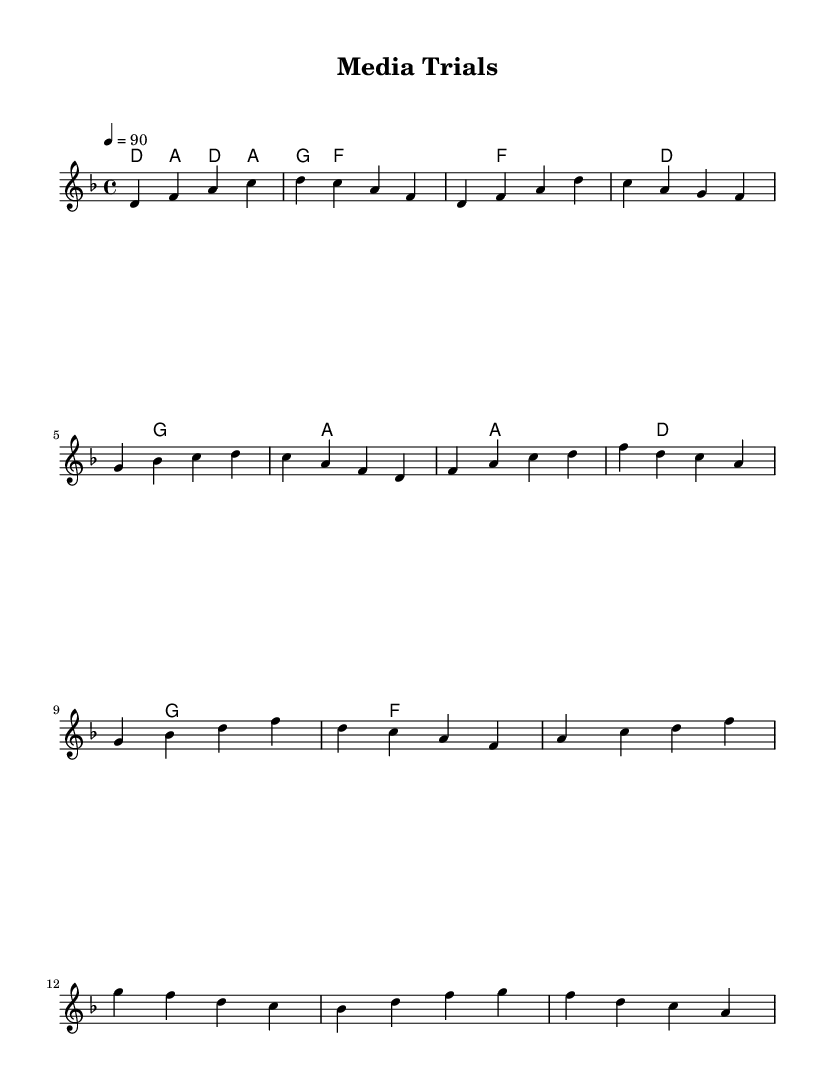What is the key signature of this music? The key signature is D minor, which contains one flat (B flat). It can be identified by looking at the left side of the staff, where the flats are indicated.
Answer: D minor What is the time signature of this music? The time signature is 4/4. This is found at the beginning of the score, indicating that there are four beats in each measure and the quarter note receives one beat.
Answer: 4/4 What is the tempo marking for this piece? The tempo is marked at 90 beats per minute, which is indicated above the staff. This guides the performer on how fast to play the piece.
Answer: 90 How many sections are there in the music? The music has four distinct sections: Intro, Verse, Chorus, and Bridge. This can be determined by examining the structure indicated in the melody part where each section is labeled or separated.
Answer: Four What chords are used in the chorus? The chords used in the chorus are F, D minor, G, and A minor. These can be found under the chorus section in the harmonies part, where the corresponding chord symbols are written.
Answer: F, D minor, G, A minor Which musical element is most suited for rap? The element that is most suited for rap is rhythm. In rap, rhythm plays a crucial role as it drives the flow and timing of lyrics. This is evident in how the melody is structured with clear beats and rhythmic patterns.
Answer: Rhythm What type of lyrical content does this rap explore? This rap explores socially conscious themes, particularly the impact of media on high-profile criminal cases. This is suggested by the title "Media Trials" and is reflective of a common purpose in socially conscious rap.
Answer: Socially conscious themes 